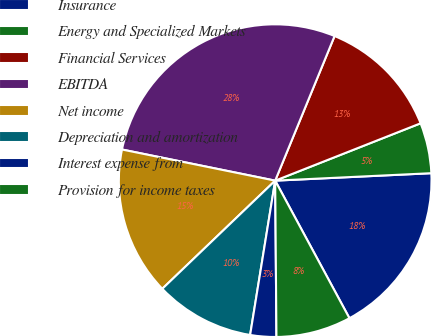<chart> <loc_0><loc_0><loc_500><loc_500><pie_chart><fcel>Insurance<fcel>Energy and Specialized Markets<fcel>Financial Services<fcel>EBITDA<fcel>Net income<fcel>Depreciation and amortization<fcel>Interest expense from<fcel>Provision for income taxes<nl><fcel>17.88%<fcel>5.22%<fcel>12.82%<fcel>28.01%<fcel>15.35%<fcel>10.28%<fcel>2.69%<fcel>7.75%<nl></chart> 